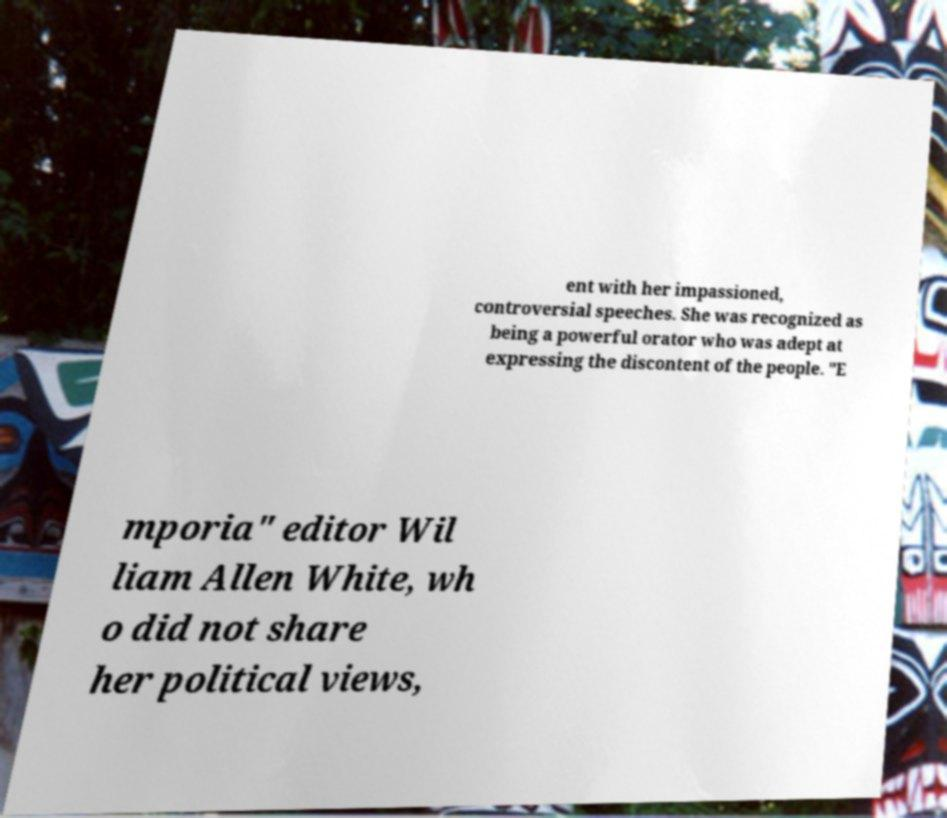For documentation purposes, I need the text within this image transcribed. Could you provide that? ent with her impassioned, controversial speeches. She was recognized as being a powerful orator who was adept at expressing the discontent of the people. "E mporia" editor Wil liam Allen White, wh o did not share her political views, 